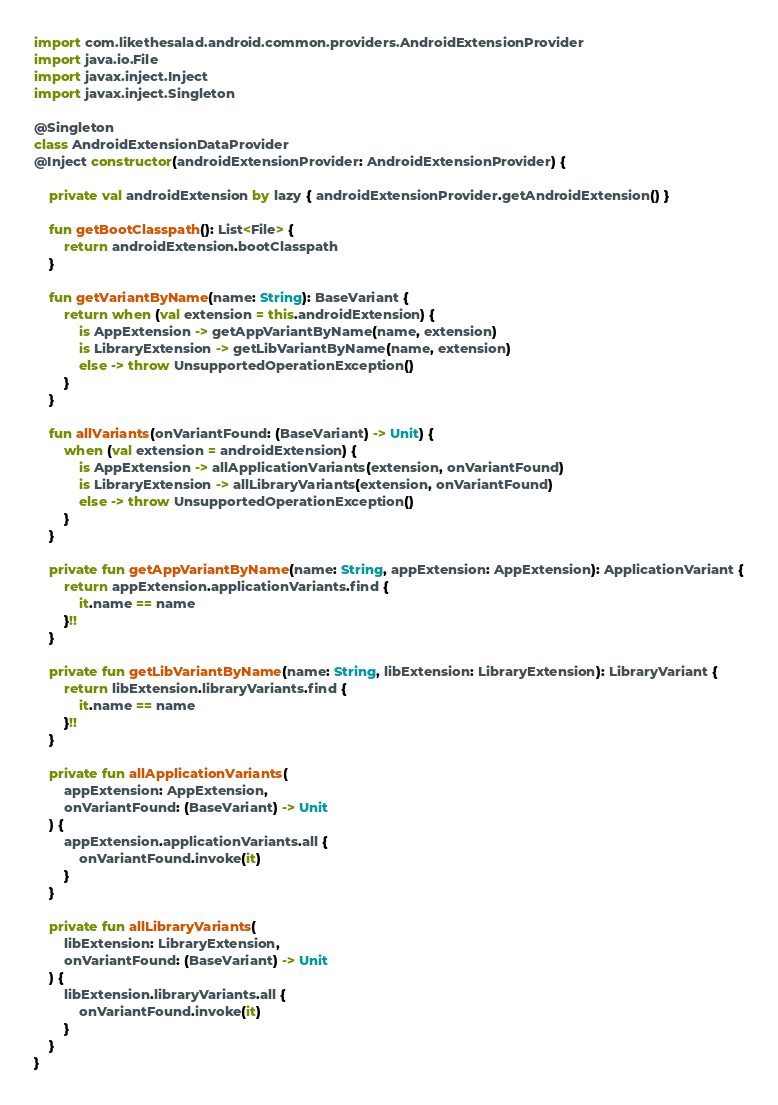Convert code to text. <code><loc_0><loc_0><loc_500><loc_500><_Kotlin_>import com.likethesalad.android.common.providers.AndroidExtensionProvider
import java.io.File
import javax.inject.Inject
import javax.inject.Singleton

@Singleton
class AndroidExtensionDataProvider
@Inject constructor(androidExtensionProvider: AndroidExtensionProvider) {

    private val androidExtension by lazy { androidExtensionProvider.getAndroidExtension() }

    fun getBootClasspath(): List<File> {
        return androidExtension.bootClasspath
    }

    fun getVariantByName(name: String): BaseVariant {
        return when (val extension = this.androidExtension) {
            is AppExtension -> getAppVariantByName(name, extension)
            is LibraryExtension -> getLibVariantByName(name, extension)
            else -> throw UnsupportedOperationException()
        }
    }

    fun allVariants(onVariantFound: (BaseVariant) -> Unit) {
        when (val extension = androidExtension) {
            is AppExtension -> allApplicationVariants(extension, onVariantFound)
            is LibraryExtension -> allLibraryVariants(extension, onVariantFound)
            else -> throw UnsupportedOperationException()
        }
    }

    private fun getAppVariantByName(name: String, appExtension: AppExtension): ApplicationVariant {
        return appExtension.applicationVariants.find {
            it.name == name
        }!!
    }

    private fun getLibVariantByName(name: String, libExtension: LibraryExtension): LibraryVariant {
        return libExtension.libraryVariants.find {
            it.name == name
        }!!
    }

    private fun allApplicationVariants(
        appExtension: AppExtension,
        onVariantFound: (BaseVariant) -> Unit
    ) {
        appExtension.applicationVariants.all {
            onVariantFound.invoke(it)
        }
    }

    private fun allLibraryVariants(
        libExtension: LibraryExtension,
        onVariantFound: (BaseVariant) -> Unit
    ) {
        libExtension.libraryVariants.all {
            onVariantFound.invoke(it)
        }
    }
}

</code> 